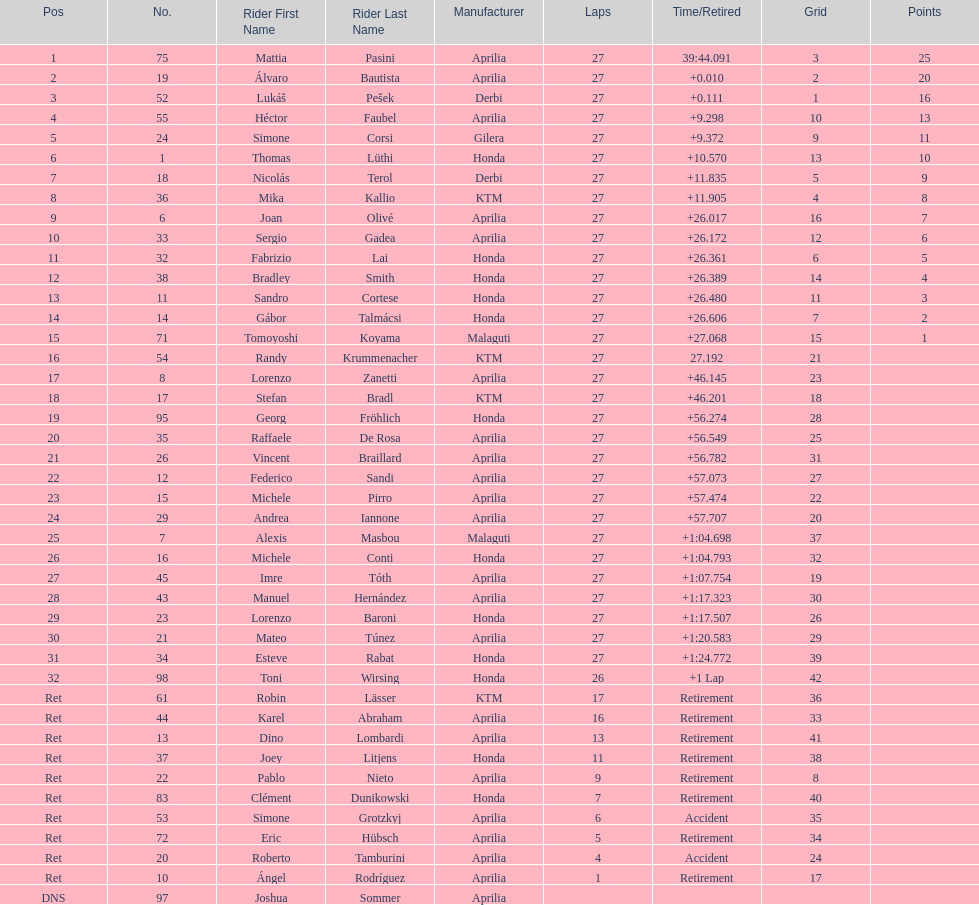Who placed higher, bradl or gadea? Sergio Gadea. 